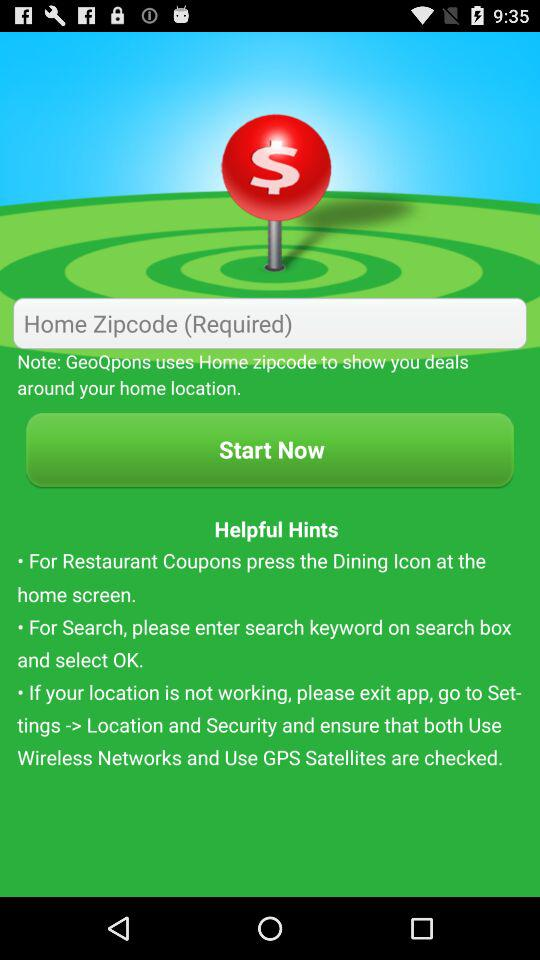What needs to be ensured for proper location? For proper location, ensure that both "Use Wireless Networks" and "Use GPS Satellites" are checked. 